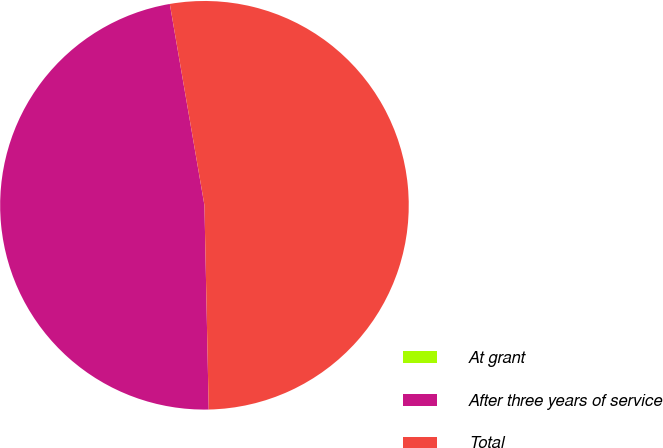Convert chart. <chart><loc_0><loc_0><loc_500><loc_500><pie_chart><fcel>At grant<fcel>After three years of service<fcel>Total<nl><fcel>0.0%<fcel>47.62%<fcel>52.38%<nl></chart> 